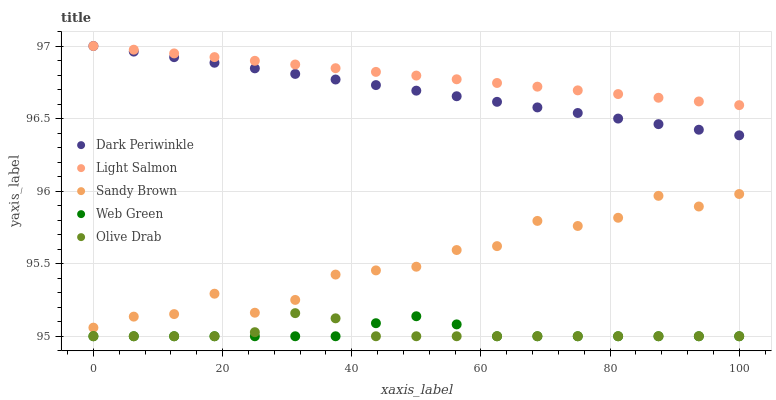Does Web Green have the minimum area under the curve?
Answer yes or no. Yes. Does Light Salmon have the maximum area under the curve?
Answer yes or no. Yes. Does Sandy Brown have the minimum area under the curve?
Answer yes or no. No. Does Sandy Brown have the maximum area under the curve?
Answer yes or no. No. Is Light Salmon the smoothest?
Answer yes or no. Yes. Is Sandy Brown the roughest?
Answer yes or no. Yes. Is Sandy Brown the smoothest?
Answer yes or no. No. Is Light Salmon the roughest?
Answer yes or no. No. Does Olive Drab have the lowest value?
Answer yes or no. Yes. Does Sandy Brown have the lowest value?
Answer yes or no. No. Does Dark Periwinkle have the highest value?
Answer yes or no. Yes. Does Sandy Brown have the highest value?
Answer yes or no. No. Is Olive Drab less than Sandy Brown?
Answer yes or no. Yes. Is Sandy Brown greater than Olive Drab?
Answer yes or no. Yes. Does Olive Drab intersect Web Green?
Answer yes or no. Yes. Is Olive Drab less than Web Green?
Answer yes or no. No. Is Olive Drab greater than Web Green?
Answer yes or no. No. Does Olive Drab intersect Sandy Brown?
Answer yes or no. No. 